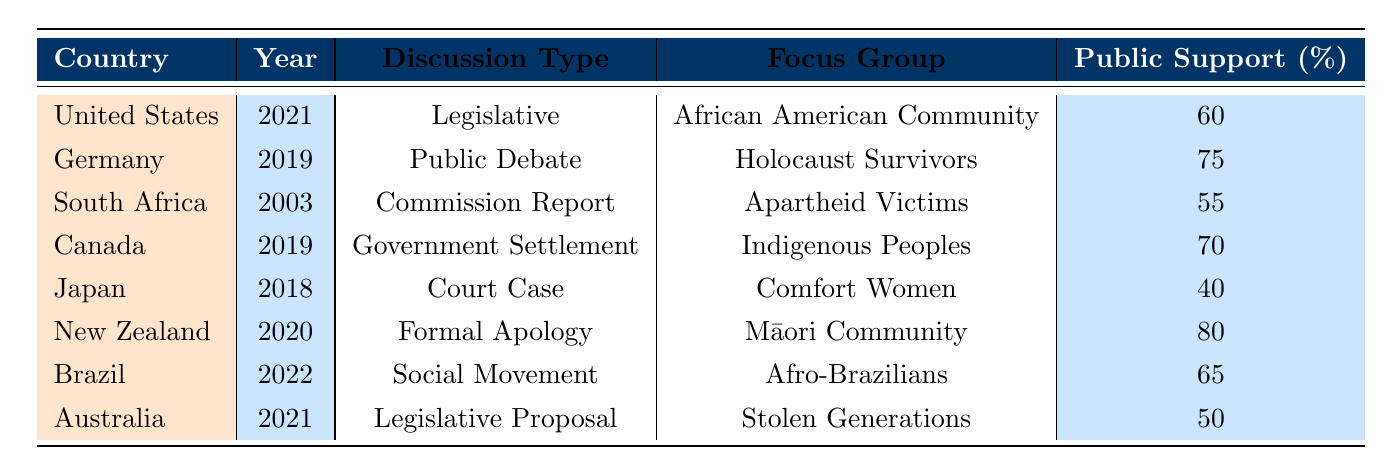What is the public support percentage for reparations discussions in Germany? The table indicates that Germany has a public support percentage of 75% for the discussions relating to Holocaust Survivors in 2019.
Answer: 75% Which country had the lowest public support percentage for reparations discussions? By examining the public support percentages listed in the table, Japan has the lowest support at 40% for the Comfort Women focus group in 2018.
Answer: Japan How many countries had a public support percentage above 60%? The countries with public support above 60% are Germany (75%), Canada (70%), New Zealand (80%), and Brazil (65%). That totals to four countries.
Answer: 4 What was the discussion type for reparations in Australia? According to the table, Australia had a Legislative Proposal discussion type in 2021 focusing on the Stolen Generations.
Answer: Legislative Proposal Is the public support for reparations discussions in Brazil greater than 60%? The table shows that Brazil has a public support percentage of 65%, which is indeed greater than 60%.
Answer: Yes What is the average public support percentage for all countries listed? To find the average, we sum the public support percentages: 60 + 75 + 55 + 70 + 40 + 80 + 65 + 50 = 455. Then, divide by the number of entries (8): 455 / 8 = 56.875. Therefore, the average public support percentage is approximately 56.88%.
Answer: 56.88% Which country focused on the Māori Community and what was the outcome? The table indicates that New Zealand focused on the Māori Community in 2020, resulting in apologies and financial reparations.
Answer: New Zealand; Apologies and financial reparations Were there any discussions focused on Indigenous Peoples? Yes, the table shows that Canada had a discussion in 2019 focusing on Indigenous Peoples with a government settlement outcome.
Answer: Yes What is the difference in public support percentages between the United States and South Africa? The public support percentage for the United States is 60%, and for South Africa, it is 55%. The difference is calculated by subtracting 55 from 60, yielding a difference of 5%.
Answer: 5% 